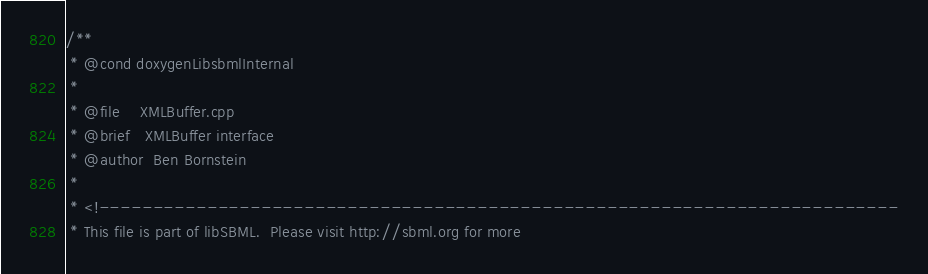Convert code to text. <code><loc_0><loc_0><loc_500><loc_500><_C++_>/**
 * @cond doxygenLibsbmlInternal
 *
 * @file    XMLBuffer.cpp
 * @brief   XMLBuffer interface
 * @author  Ben Bornstein
 * 
 * <!--------------------------------------------------------------------------
 * This file is part of libSBML.  Please visit http://sbml.org for more</code> 